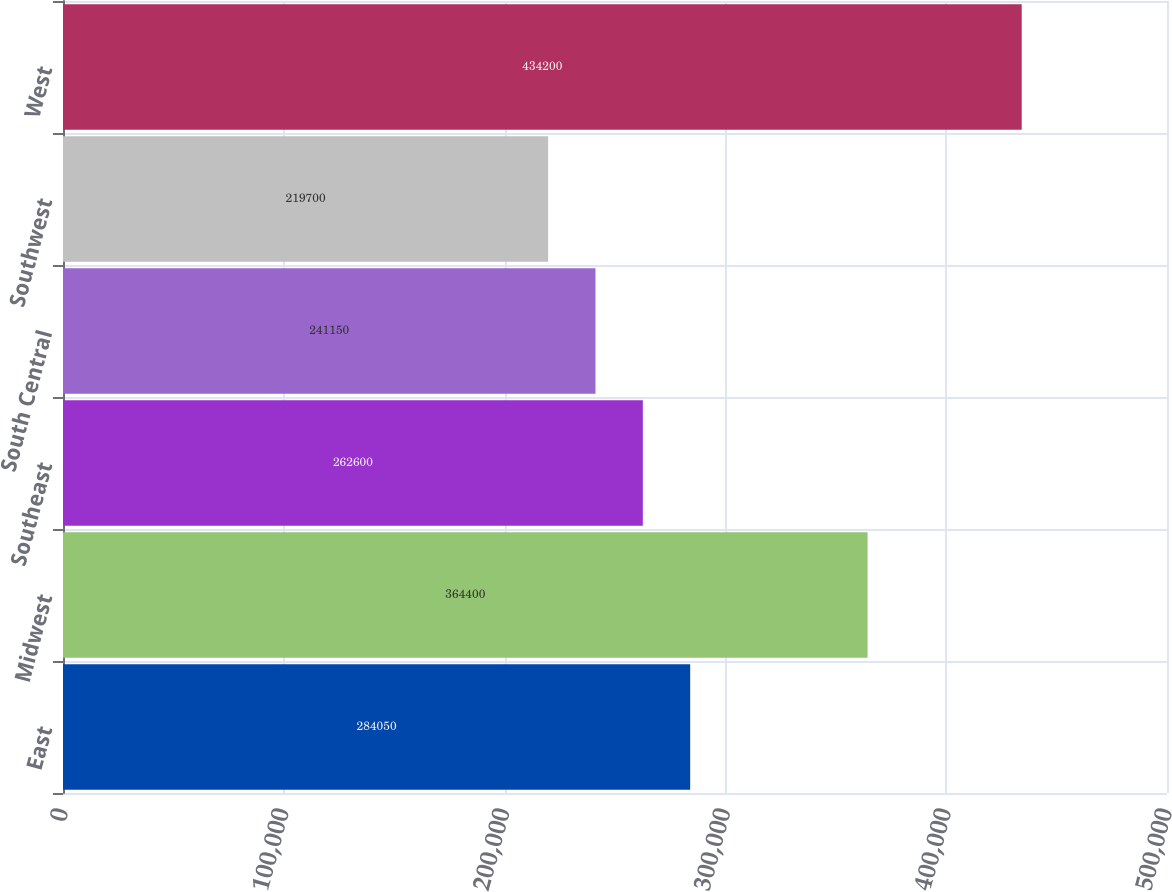Convert chart. <chart><loc_0><loc_0><loc_500><loc_500><bar_chart><fcel>East<fcel>Midwest<fcel>Southeast<fcel>South Central<fcel>Southwest<fcel>West<nl><fcel>284050<fcel>364400<fcel>262600<fcel>241150<fcel>219700<fcel>434200<nl></chart> 